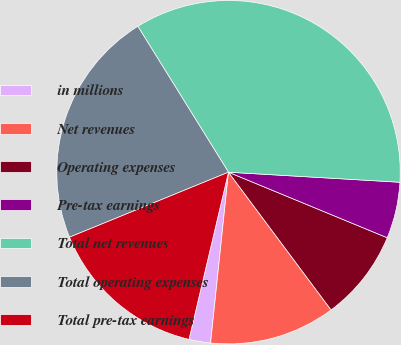<chart> <loc_0><loc_0><loc_500><loc_500><pie_chart><fcel>in millions<fcel>Net revenues<fcel>Operating expenses<fcel>Pre-tax earnings<fcel>Total net revenues<fcel>Total operating expenses<fcel>Total pre-tax earnings<nl><fcel>2.03%<fcel>11.85%<fcel>8.58%<fcel>5.3%<fcel>34.78%<fcel>22.33%<fcel>15.13%<nl></chart> 